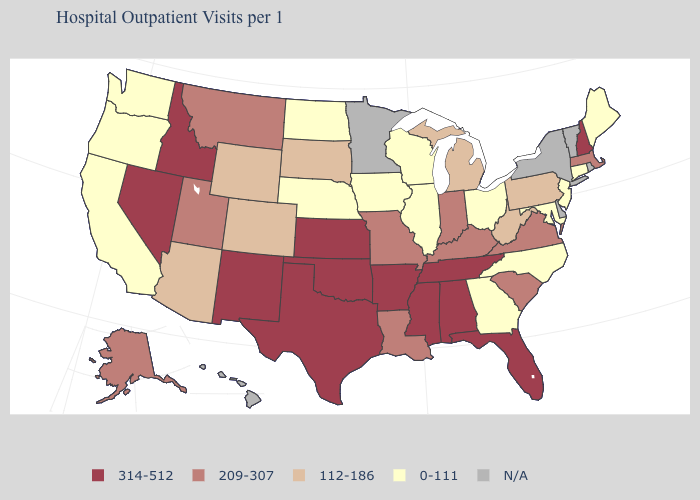Does Kansas have the highest value in the USA?
Keep it brief. Yes. Among the states that border Wyoming , which have the lowest value?
Concise answer only. Nebraska. What is the value of Texas?
Be succinct. 314-512. Does Connecticut have the lowest value in the USA?
Give a very brief answer. Yes. Does New Hampshire have the highest value in the USA?
Write a very short answer. Yes. What is the lowest value in states that border South Carolina?
Concise answer only. 0-111. Is the legend a continuous bar?
Keep it brief. No. Does Oklahoma have the lowest value in the USA?
Give a very brief answer. No. Name the states that have a value in the range 314-512?
Quick response, please. Alabama, Arkansas, Florida, Idaho, Kansas, Mississippi, Nevada, New Hampshire, New Mexico, Oklahoma, Tennessee, Texas. Does the map have missing data?
Be succinct. Yes. What is the value of Colorado?
Short answer required. 112-186. What is the value of Rhode Island?
Keep it brief. N/A. What is the value of Massachusetts?
Short answer required. 209-307. What is the value of Florida?
Concise answer only. 314-512. 